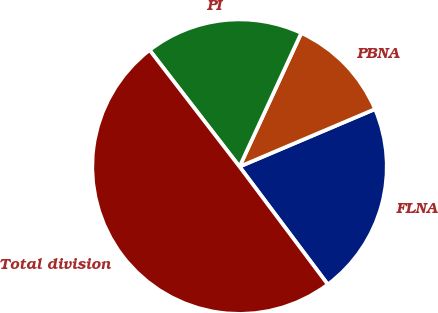Convert chart. <chart><loc_0><loc_0><loc_500><loc_500><pie_chart><fcel>FLNA<fcel>PBNA<fcel>PI<fcel>Total division<nl><fcel>21.16%<fcel>11.72%<fcel>17.35%<fcel>49.78%<nl></chart> 